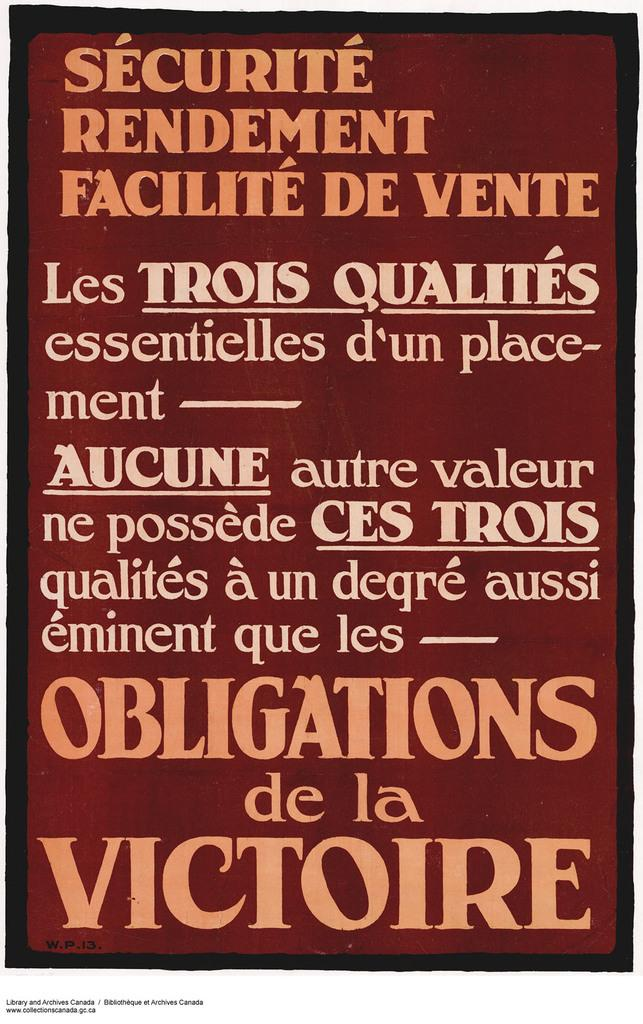<image>
Describe the image concisely. A red sign reads "OBLIGATIONS de la VICTOIRE" at the bottom. 